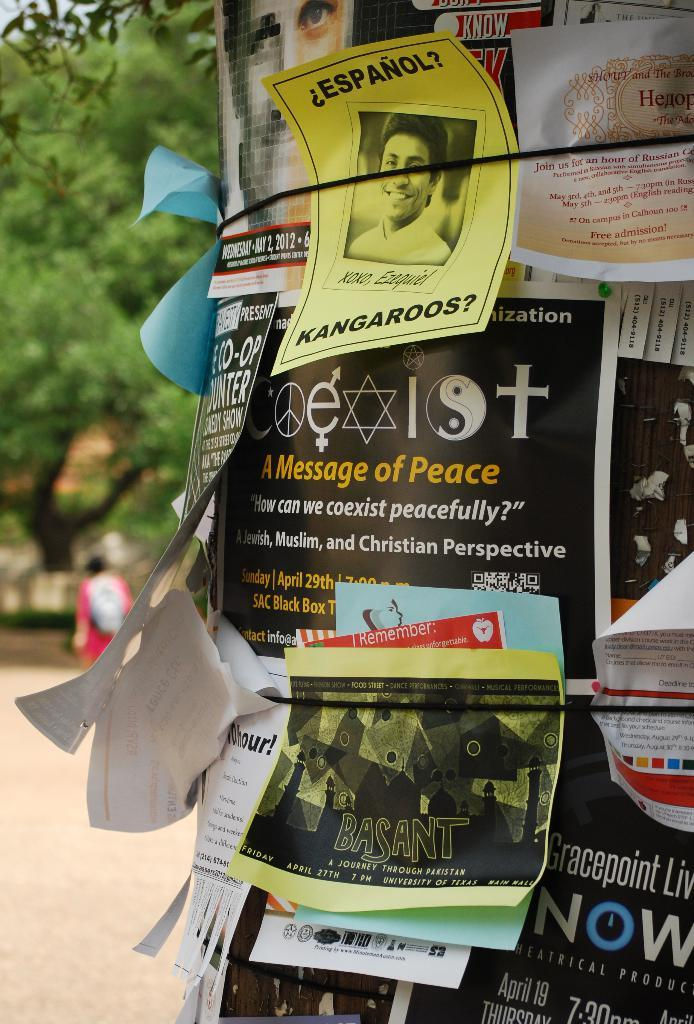<image>
Summarize the visual content of the image. A yellow sign has black letters that spell Espanol. 